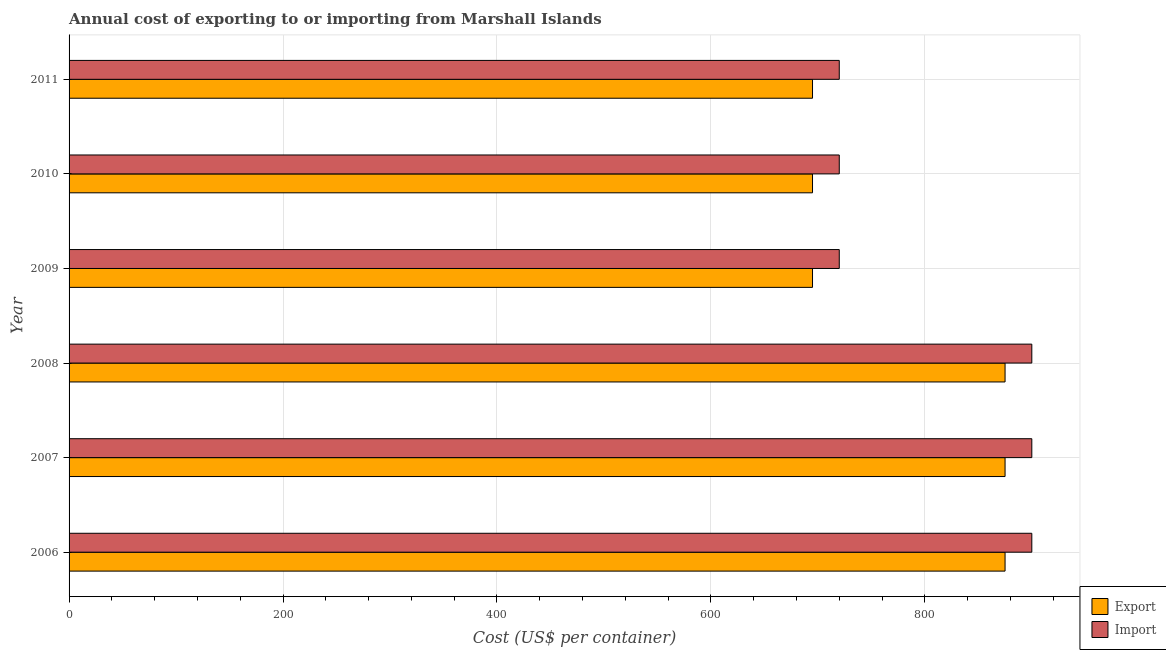How many groups of bars are there?
Keep it short and to the point. 6. Are the number of bars per tick equal to the number of legend labels?
Offer a very short reply. Yes. Are the number of bars on each tick of the Y-axis equal?
Offer a terse response. Yes. What is the label of the 6th group of bars from the top?
Your response must be concise. 2006. What is the export cost in 2009?
Make the answer very short. 695. Across all years, what is the maximum export cost?
Your answer should be very brief. 875. Across all years, what is the minimum import cost?
Ensure brevity in your answer.  720. In which year was the export cost maximum?
Give a very brief answer. 2006. What is the total export cost in the graph?
Offer a terse response. 4710. What is the difference between the export cost in 2006 and that in 2009?
Make the answer very short. 180. What is the difference between the export cost in 2009 and the import cost in 2010?
Your answer should be very brief. -25. What is the average export cost per year?
Your answer should be compact. 785. In the year 2009, what is the difference between the import cost and export cost?
Offer a terse response. 25. In how many years, is the export cost greater than 400 US$?
Provide a succinct answer. 6. What is the difference between the highest and the lowest import cost?
Provide a succinct answer. 180. What does the 2nd bar from the top in 2006 represents?
Offer a very short reply. Export. What does the 2nd bar from the bottom in 2011 represents?
Your answer should be compact. Import. Are all the bars in the graph horizontal?
Provide a succinct answer. Yes. How many years are there in the graph?
Give a very brief answer. 6. What is the difference between two consecutive major ticks on the X-axis?
Provide a short and direct response. 200. Are the values on the major ticks of X-axis written in scientific E-notation?
Provide a succinct answer. No. Does the graph contain any zero values?
Make the answer very short. No. How are the legend labels stacked?
Your answer should be compact. Vertical. What is the title of the graph?
Provide a short and direct response. Annual cost of exporting to or importing from Marshall Islands. What is the label or title of the X-axis?
Your answer should be very brief. Cost (US$ per container). What is the Cost (US$ per container) in Export in 2006?
Offer a terse response. 875. What is the Cost (US$ per container) of Import in 2006?
Make the answer very short. 900. What is the Cost (US$ per container) in Export in 2007?
Provide a short and direct response. 875. What is the Cost (US$ per container) of Import in 2007?
Provide a succinct answer. 900. What is the Cost (US$ per container) in Export in 2008?
Ensure brevity in your answer.  875. What is the Cost (US$ per container) of Import in 2008?
Provide a succinct answer. 900. What is the Cost (US$ per container) in Export in 2009?
Make the answer very short. 695. What is the Cost (US$ per container) in Import in 2009?
Offer a terse response. 720. What is the Cost (US$ per container) of Export in 2010?
Provide a succinct answer. 695. What is the Cost (US$ per container) in Import in 2010?
Give a very brief answer. 720. What is the Cost (US$ per container) in Export in 2011?
Provide a short and direct response. 695. What is the Cost (US$ per container) of Import in 2011?
Give a very brief answer. 720. Across all years, what is the maximum Cost (US$ per container) in Export?
Ensure brevity in your answer.  875. Across all years, what is the maximum Cost (US$ per container) in Import?
Provide a succinct answer. 900. Across all years, what is the minimum Cost (US$ per container) of Export?
Provide a succinct answer. 695. Across all years, what is the minimum Cost (US$ per container) of Import?
Make the answer very short. 720. What is the total Cost (US$ per container) in Export in the graph?
Your response must be concise. 4710. What is the total Cost (US$ per container) of Import in the graph?
Keep it short and to the point. 4860. What is the difference between the Cost (US$ per container) in Import in 2006 and that in 2007?
Offer a terse response. 0. What is the difference between the Cost (US$ per container) in Export in 2006 and that in 2009?
Give a very brief answer. 180. What is the difference between the Cost (US$ per container) in Import in 2006 and that in 2009?
Give a very brief answer. 180. What is the difference between the Cost (US$ per container) in Export in 2006 and that in 2010?
Make the answer very short. 180. What is the difference between the Cost (US$ per container) in Import in 2006 and that in 2010?
Make the answer very short. 180. What is the difference between the Cost (US$ per container) in Export in 2006 and that in 2011?
Keep it short and to the point. 180. What is the difference between the Cost (US$ per container) in Import in 2006 and that in 2011?
Make the answer very short. 180. What is the difference between the Cost (US$ per container) in Export in 2007 and that in 2008?
Offer a terse response. 0. What is the difference between the Cost (US$ per container) in Export in 2007 and that in 2009?
Offer a very short reply. 180. What is the difference between the Cost (US$ per container) of Import in 2007 and that in 2009?
Provide a short and direct response. 180. What is the difference between the Cost (US$ per container) in Export in 2007 and that in 2010?
Your answer should be very brief. 180. What is the difference between the Cost (US$ per container) of Import in 2007 and that in 2010?
Your response must be concise. 180. What is the difference between the Cost (US$ per container) in Export in 2007 and that in 2011?
Give a very brief answer. 180. What is the difference between the Cost (US$ per container) in Import in 2007 and that in 2011?
Your response must be concise. 180. What is the difference between the Cost (US$ per container) of Export in 2008 and that in 2009?
Provide a succinct answer. 180. What is the difference between the Cost (US$ per container) in Import in 2008 and that in 2009?
Offer a very short reply. 180. What is the difference between the Cost (US$ per container) in Export in 2008 and that in 2010?
Your answer should be very brief. 180. What is the difference between the Cost (US$ per container) of Import in 2008 and that in 2010?
Your answer should be very brief. 180. What is the difference between the Cost (US$ per container) of Export in 2008 and that in 2011?
Provide a succinct answer. 180. What is the difference between the Cost (US$ per container) of Import in 2008 and that in 2011?
Ensure brevity in your answer.  180. What is the difference between the Cost (US$ per container) in Import in 2009 and that in 2011?
Provide a short and direct response. 0. What is the difference between the Cost (US$ per container) in Export in 2010 and that in 2011?
Make the answer very short. 0. What is the difference between the Cost (US$ per container) of Export in 2006 and the Cost (US$ per container) of Import in 2007?
Provide a succinct answer. -25. What is the difference between the Cost (US$ per container) of Export in 2006 and the Cost (US$ per container) of Import in 2009?
Provide a short and direct response. 155. What is the difference between the Cost (US$ per container) of Export in 2006 and the Cost (US$ per container) of Import in 2010?
Your response must be concise. 155. What is the difference between the Cost (US$ per container) in Export in 2006 and the Cost (US$ per container) in Import in 2011?
Provide a succinct answer. 155. What is the difference between the Cost (US$ per container) in Export in 2007 and the Cost (US$ per container) in Import in 2008?
Offer a terse response. -25. What is the difference between the Cost (US$ per container) in Export in 2007 and the Cost (US$ per container) in Import in 2009?
Provide a succinct answer. 155. What is the difference between the Cost (US$ per container) in Export in 2007 and the Cost (US$ per container) in Import in 2010?
Make the answer very short. 155. What is the difference between the Cost (US$ per container) of Export in 2007 and the Cost (US$ per container) of Import in 2011?
Your answer should be very brief. 155. What is the difference between the Cost (US$ per container) in Export in 2008 and the Cost (US$ per container) in Import in 2009?
Offer a terse response. 155. What is the difference between the Cost (US$ per container) of Export in 2008 and the Cost (US$ per container) of Import in 2010?
Give a very brief answer. 155. What is the difference between the Cost (US$ per container) of Export in 2008 and the Cost (US$ per container) of Import in 2011?
Your answer should be compact. 155. What is the difference between the Cost (US$ per container) of Export in 2009 and the Cost (US$ per container) of Import in 2010?
Your answer should be very brief. -25. What is the average Cost (US$ per container) of Export per year?
Keep it short and to the point. 785. What is the average Cost (US$ per container) of Import per year?
Give a very brief answer. 810. In the year 2007, what is the difference between the Cost (US$ per container) of Export and Cost (US$ per container) of Import?
Your answer should be compact. -25. In the year 2008, what is the difference between the Cost (US$ per container) of Export and Cost (US$ per container) of Import?
Keep it short and to the point. -25. In the year 2009, what is the difference between the Cost (US$ per container) in Export and Cost (US$ per container) in Import?
Offer a very short reply. -25. In the year 2010, what is the difference between the Cost (US$ per container) of Export and Cost (US$ per container) of Import?
Your response must be concise. -25. What is the ratio of the Cost (US$ per container) of Import in 2006 to that in 2007?
Provide a succinct answer. 1. What is the ratio of the Cost (US$ per container) in Export in 2006 to that in 2008?
Your response must be concise. 1. What is the ratio of the Cost (US$ per container) in Import in 2006 to that in 2008?
Provide a succinct answer. 1. What is the ratio of the Cost (US$ per container) of Export in 2006 to that in 2009?
Give a very brief answer. 1.26. What is the ratio of the Cost (US$ per container) of Export in 2006 to that in 2010?
Give a very brief answer. 1.26. What is the ratio of the Cost (US$ per container) of Import in 2006 to that in 2010?
Ensure brevity in your answer.  1.25. What is the ratio of the Cost (US$ per container) in Export in 2006 to that in 2011?
Your answer should be very brief. 1.26. What is the ratio of the Cost (US$ per container) in Export in 2007 to that in 2009?
Give a very brief answer. 1.26. What is the ratio of the Cost (US$ per container) of Export in 2007 to that in 2010?
Make the answer very short. 1.26. What is the ratio of the Cost (US$ per container) in Import in 2007 to that in 2010?
Provide a succinct answer. 1.25. What is the ratio of the Cost (US$ per container) in Export in 2007 to that in 2011?
Provide a short and direct response. 1.26. What is the ratio of the Cost (US$ per container) in Import in 2007 to that in 2011?
Ensure brevity in your answer.  1.25. What is the ratio of the Cost (US$ per container) in Export in 2008 to that in 2009?
Make the answer very short. 1.26. What is the ratio of the Cost (US$ per container) in Export in 2008 to that in 2010?
Ensure brevity in your answer.  1.26. What is the ratio of the Cost (US$ per container) of Import in 2008 to that in 2010?
Offer a terse response. 1.25. What is the ratio of the Cost (US$ per container) in Export in 2008 to that in 2011?
Your answer should be very brief. 1.26. What is the ratio of the Cost (US$ per container) of Import in 2009 to that in 2010?
Offer a very short reply. 1. What is the ratio of the Cost (US$ per container) in Export in 2009 to that in 2011?
Provide a succinct answer. 1. What is the ratio of the Cost (US$ per container) of Import in 2009 to that in 2011?
Provide a short and direct response. 1. What is the ratio of the Cost (US$ per container) in Import in 2010 to that in 2011?
Your answer should be very brief. 1. What is the difference between the highest and the lowest Cost (US$ per container) of Export?
Your response must be concise. 180. What is the difference between the highest and the lowest Cost (US$ per container) in Import?
Provide a short and direct response. 180. 